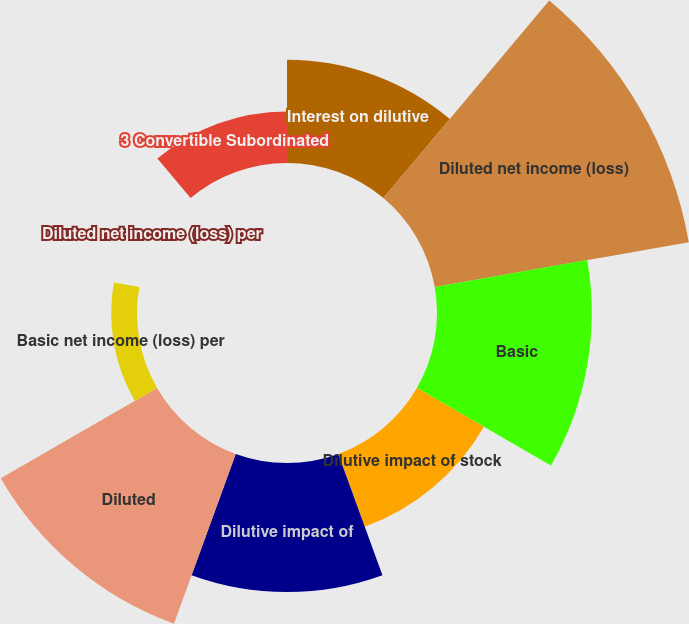Convert chart to OTSL. <chart><loc_0><loc_0><loc_500><loc_500><pie_chart><fcel>Interest on dilutive<fcel>Diluted net income (loss)<fcel>Basic<fcel>Dilutive impact of stock<fcel>Dilutive impact of<fcel>Diluted<fcel>Basic net income (loss) per<fcel>Diluted net income (loss) per<fcel>3 Convertible Subordinated<nl><fcel>10.53%<fcel>26.32%<fcel>15.79%<fcel>7.89%<fcel>13.16%<fcel>18.42%<fcel>2.63%<fcel>0.0%<fcel>5.26%<nl></chart> 